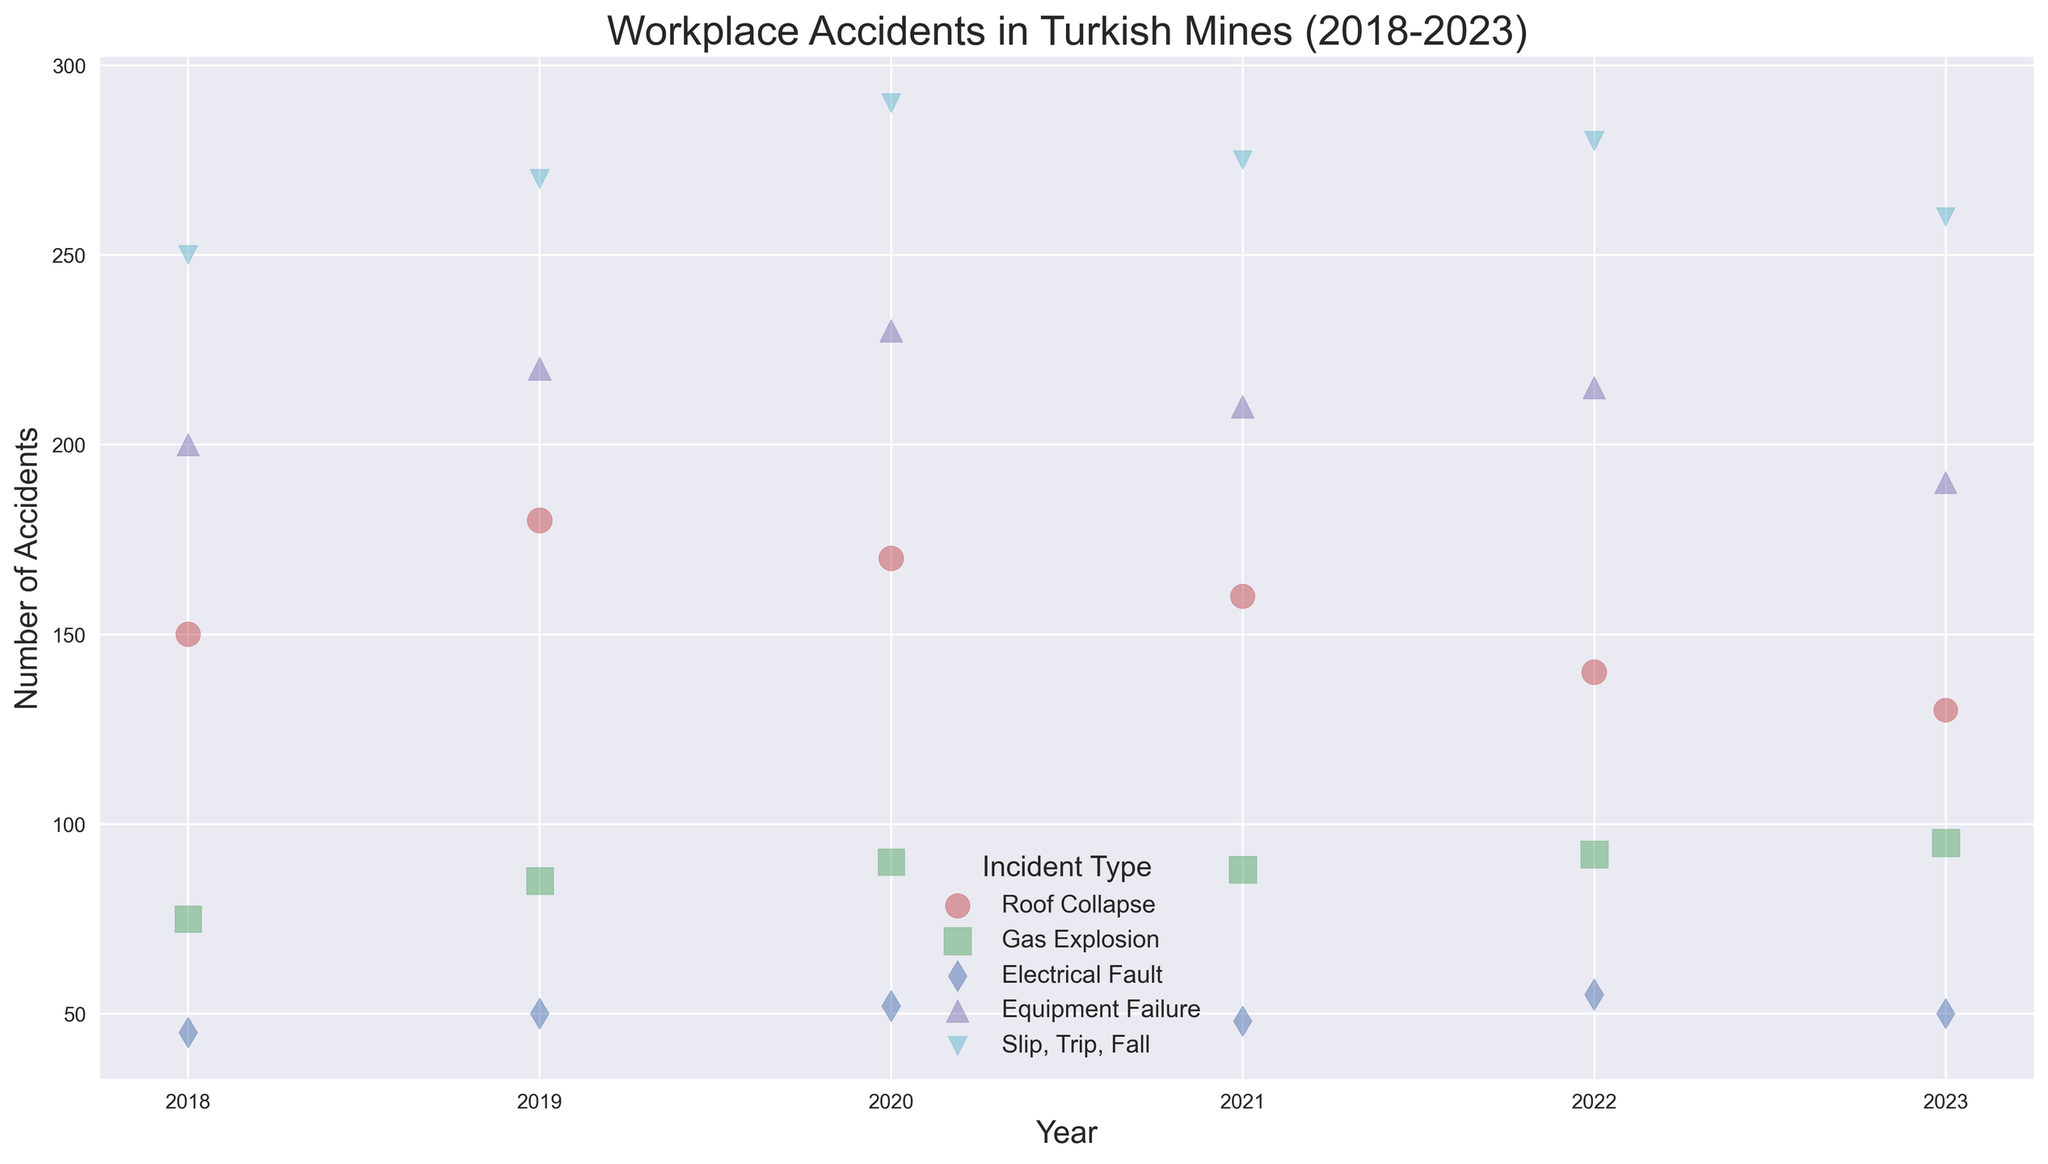What is the incident type with the highest number of accidents in 2023? Examine the data points for 2023. Identify the incident type that has the largest bubble on the x-axis denoting 2023; this will correspond to the highest number of accidents in that year.
Answer: Slip, Trip, Fall How many more accidents happened due to Gas Explosions in 2023 compared to 2018? Subtract the number of Gas Explosion accidents in 2018 from the number in 2023: 95 (2023) - 75 (2018) = 20.
Answer: 20 Which incident type had the least severe accidents in 2022, according to the severity index? Look for the incident type with the smallest bubble size in 2022. This bubble will denote the lowest severity index.
Answer: Slip, Trip, Fall Did the total number of Roof Collapse incidents increase or decrease from 2021 to 2023? Compare the total number of incidents for Roof Collapse in 2021 and 2023. In 2021, there were 160 incidents, and in 2023, there were 130 incidents. Thus, there was a decrease.
Answer: Decrease Which year had the highest number of Slip, Trip, Fall incidents? Identify the year with the largest bubble in the Slip, Trip, Fall category. The largest bubble for Slip, Trip, Fall is in 2020 with 290 incidents.
Answer: 2020 What is the average severity index of Electrical Faults over all the years? Add the severity indices for Electrical Faults over all the years and divide by the number of years: (5.7 + 5.8 + 5.9 + 5.6 + 6.0 + 5.5) / 6 = 34.5 / 6 = 5.75.
Answer: 5.75 In which year did Equipment Failure incidents peak? Identify the year with the largest bubble in the Equipment Failure category, which occurs in 2020 with 230 incidents.
Answer: 2020 Did the number of Gas Explosion incidents consistently increase each year from 2018 to 2023? Check the number of incidents each year from 2018 to 2023: 75, 85, 90, 88, 92, 95. Notice the trend is not consistent (88 in 2021 is less than 90 in 2020).
Answer: No Which incident type had the highest severity index in the year 2021? Identify the incident type with the largest bubbles in the year 2021. As Gas Explosion has the largest bubble, it has the highest severity index: 8.8.
Answer: Gas Explosion How many more Slip, Trip, Fall incidents were there in 2020 compared to 2019? Subtract the number of Slip, Trip, Fall incidents in 2019 from the number in 2020: 290 - 270 = 20.
Answer: 20 